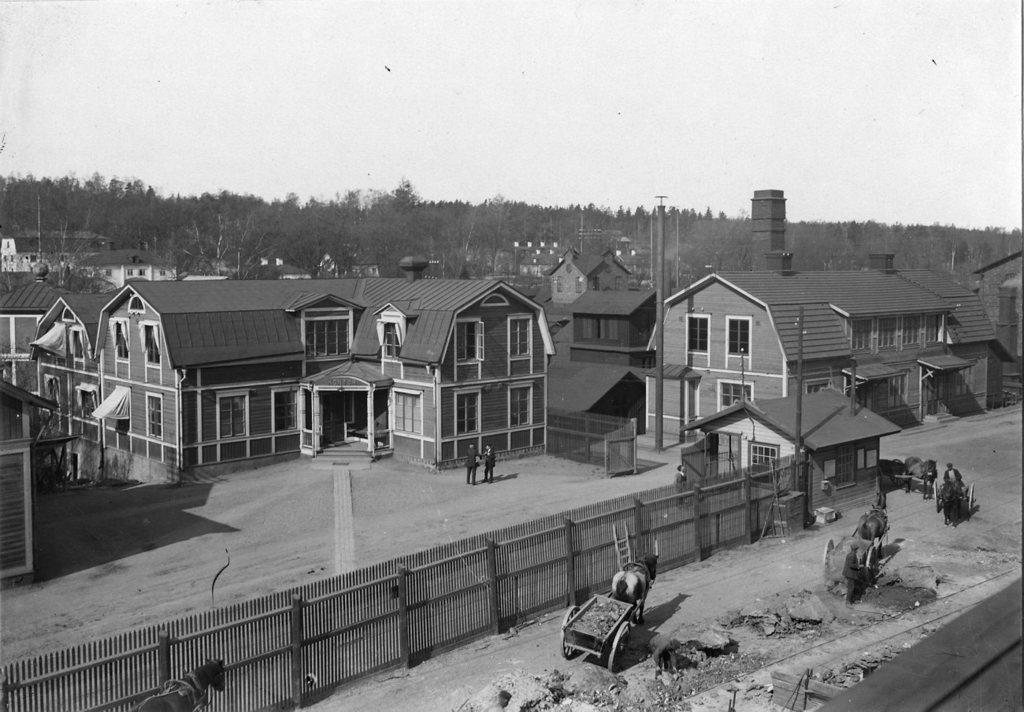Describe this image in one or two sentences. This is a black and white picture. In this picture we can see the sky, trees, buildings and people. We can see a ladder near to the wall. On the right side of the picture we can see animal carts on the ground. 